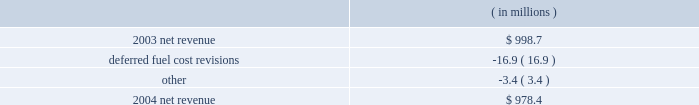Entergy arkansas , inc .
Management's financial discussion and analysis results of operations net income 2004 compared to 2003 net income increased $ 16.2 million due to lower other operation and maintenance expenses , a lower effective income tax rate for 2004 compared to 2003 , and lower interest charges .
The increase was partially offset by lower net revenue .
2003 compared to 2002 net income decreased $ 9.6 million due to lower net revenue , higher depreciation and amortization expenses , and a higher effective income tax rate for 2003 compared to 2002 .
The decrease was substantially offset by lower other operation and maintenance expenses , higher other income , and lower interest charges .
Net revenue 2004 compared to 2003 net revenue , which is entergy arkansas' measure of gross margin , consists of operating revenues net of : 1 ) fuel , fuel-related , and purchased power expenses and 2 ) other regulatory credits .
Following is an analysis of the change in net revenue comparing 2004 to 2003. .
Deferred fuel cost revisions includes the difference between the estimated deferred fuel expense and the actual calculation of recoverable fuel expense , which occurs on an annual basis .
Deferred fuel cost revisions decreased net revenue due to a revised estimate of fuel costs filed for recovery at entergy arkansas in the march 2004 energy cost recovery rider , which reduced net revenue by $ 11.5 million .
The remainder of the variance is due to the 2002 energy cost recovery true-up , made in the first quarter of 2003 , which increased net revenue in 2003 .
Gross operating revenues , fuel and purchased power expenses , and other regulatory credits gross operating revenues increased primarily due to : 2022 an increase of $ 20.7 million in fuel cost recovery revenues due to an increase in the energy cost recovery rider effective april 2004 ( fuel cost recovery revenues are discussed in note 2 to the domestic utility companies and system energy financial statements ) ; 2022 an increase of $ 15.5 million in grand gulf revenues due to an increase in the grand gulf rider effective january 2004 ; 2022 an increase of $ 13.9 million in gross wholesale revenue primarily due to increased sales to affiliated systems ; 2022 an increase of $ 9.5 million due to volume/weather primarily resulting from increased usage during the unbilled sales period , partially offset by the effect of milder weather on billed sales in 2004. .
What is the percent change in net revenue from 2003 to 2004? 
Computations: ((998.7 - 978.4) / 978.4)
Answer: 0.02075. 